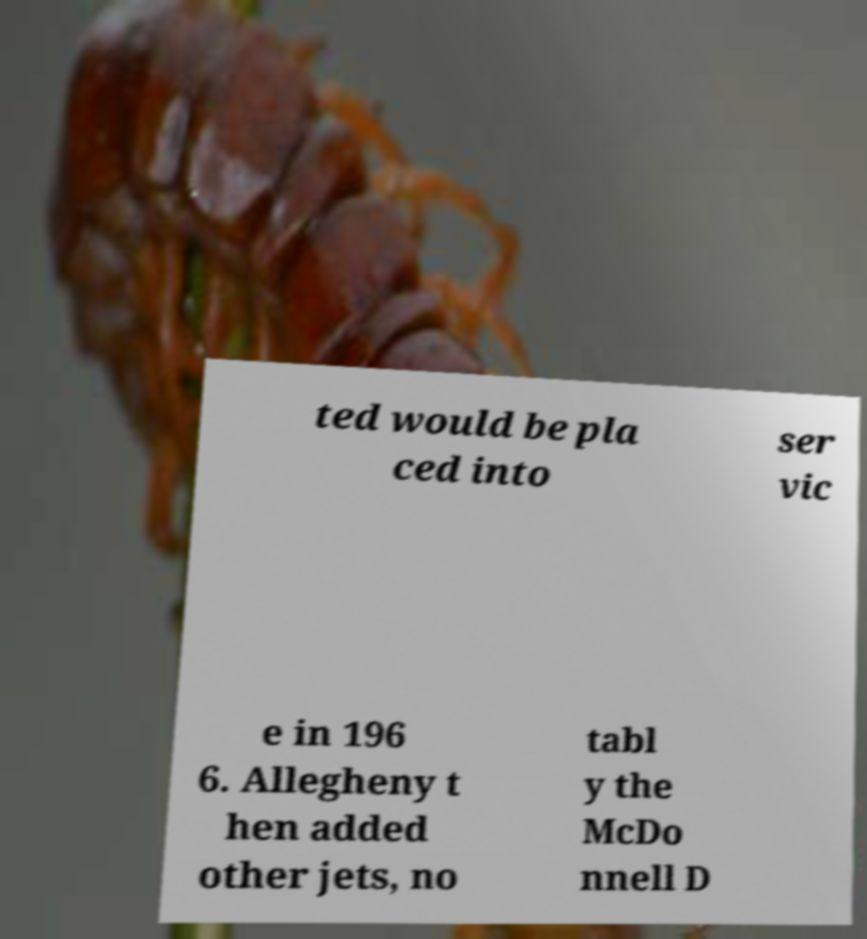For documentation purposes, I need the text within this image transcribed. Could you provide that? ted would be pla ced into ser vic e in 196 6. Allegheny t hen added other jets, no tabl y the McDo nnell D 